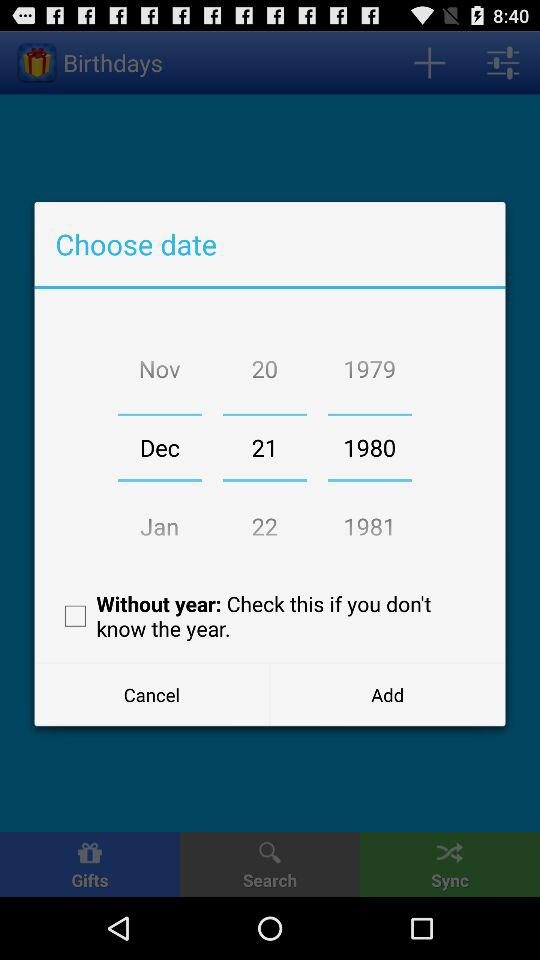What is the status of "Without year"? The status is "off". 